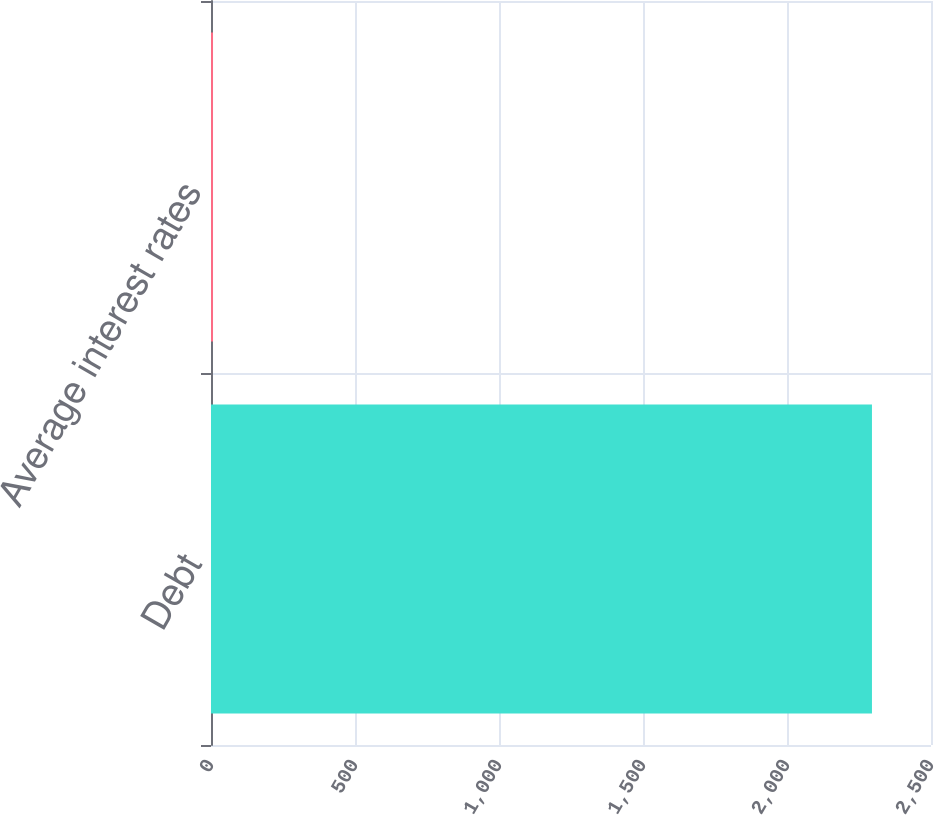Convert chart. <chart><loc_0><loc_0><loc_500><loc_500><bar_chart><fcel>Debt<fcel>Average interest rates<nl><fcel>2295<fcel>7<nl></chart> 